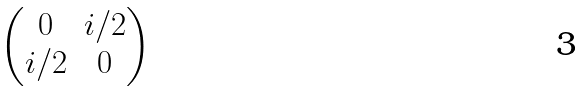<formula> <loc_0><loc_0><loc_500><loc_500>\begin{pmatrix} 0 & i / 2 \\ i / 2 & 0 \end{pmatrix}</formula> 